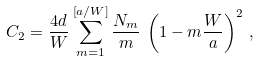Convert formula to latex. <formula><loc_0><loc_0><loc_500><loc_500>C _ { 2 } = \frac { 4 d } { W } \sum _ { m = 1 } ^ { \left [ a / W \right ] } \frac { N _ { m } } { m } \, \left ( 1 - m \frac { W } { a } \right ) ^ { 2 } \, ,</formula> 